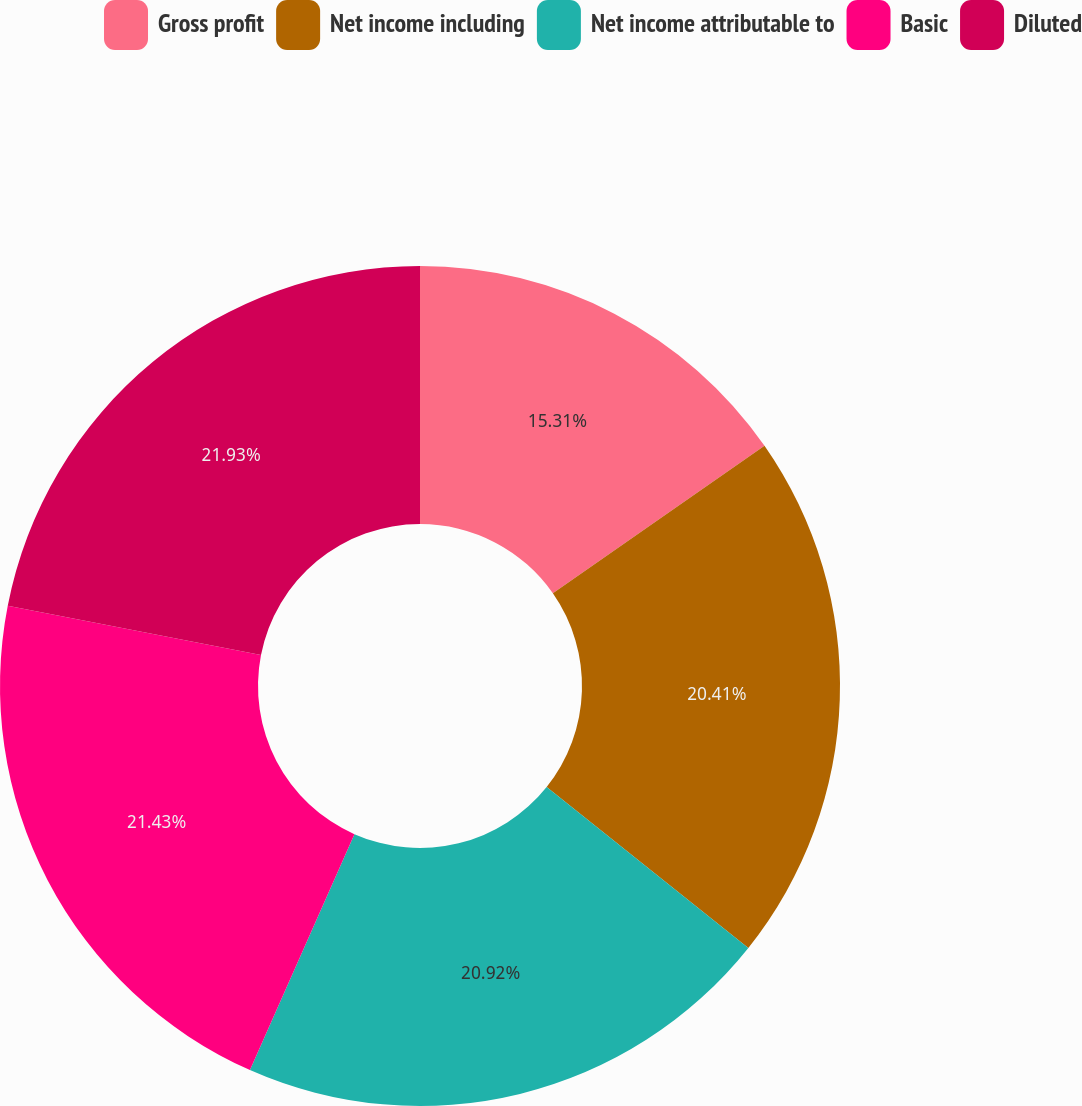Convert chart to OTSL. <chart><loc_0><loc_0><loc_500><loc_500><pie_chart><fcel>Gross profit<fcel>Net income including<fcel>Net income attributable to<fcel>Basic<fcel>Diluted<nl><fcel>15.31%<fcel>20.41%<fcel>20.92%<fcel>21.43%<fcel>21.94%<nl></chart> 